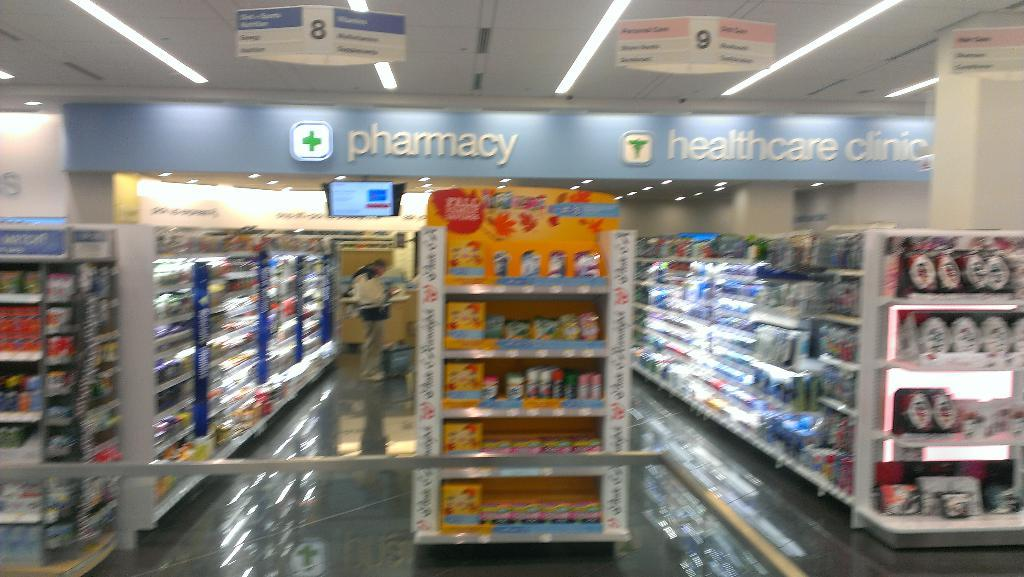<image>
Render a clear and concise summary of the photo. Looking down the aisle of a pharmacy store 